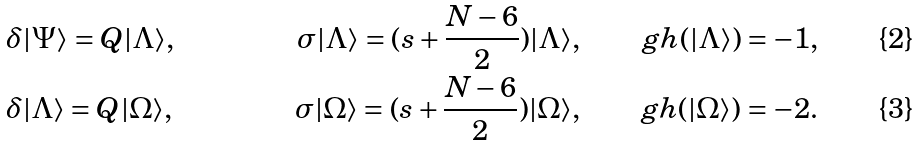Convert formula to latex. <formula><loc_0><loc_0><loc_500><loc_500>& \delta | \Psi \rangle = Q | \Lambda \rangle , & & & \sigma | \Lambda \rangle = ( s + \frac { N - 6 } { 2 } ) | \Lambda \rangle , & & g h ( | \Lambda \rangle ) = - 1 , \\ & \delta | \Lambda \rangle = Q | \Omega \rangle , & & & \sigma | \Omega \rangle = ( s + \frac { N - 6 } { 2 } ) | \Omega \rangle , & & g h ( | \Omega \rangle ) = - 2 .</formula> 